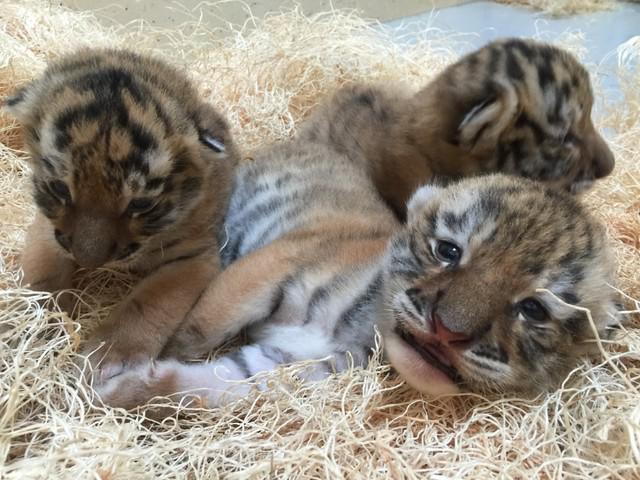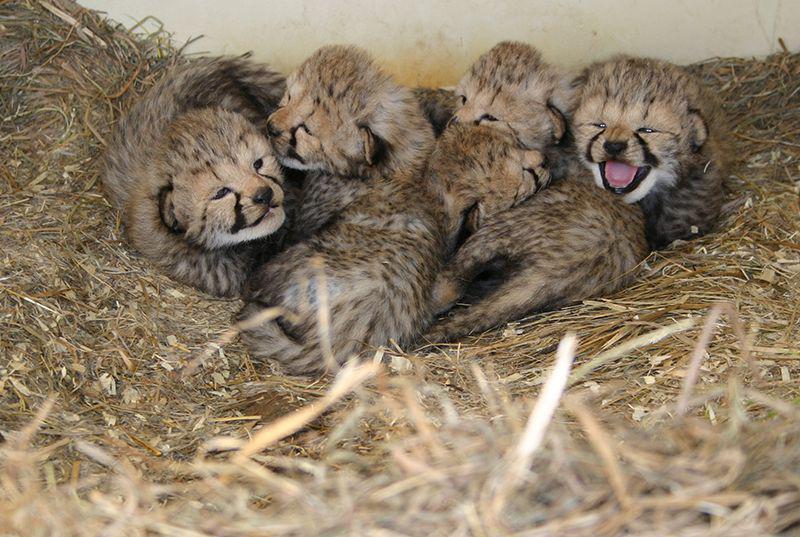The first image is the image on the left, the second image is the image on the right. Considering the images on both sides, is "the mother cheetah has two cubs next to her" valid? Answer yes or no. No. The first image is the image on the left, the second image is the image on the right. Considering the images on both sides, is "The picture on the left shows at least two baby cheetah sitting down next to their mother." valid? Answer yes or no. No. 